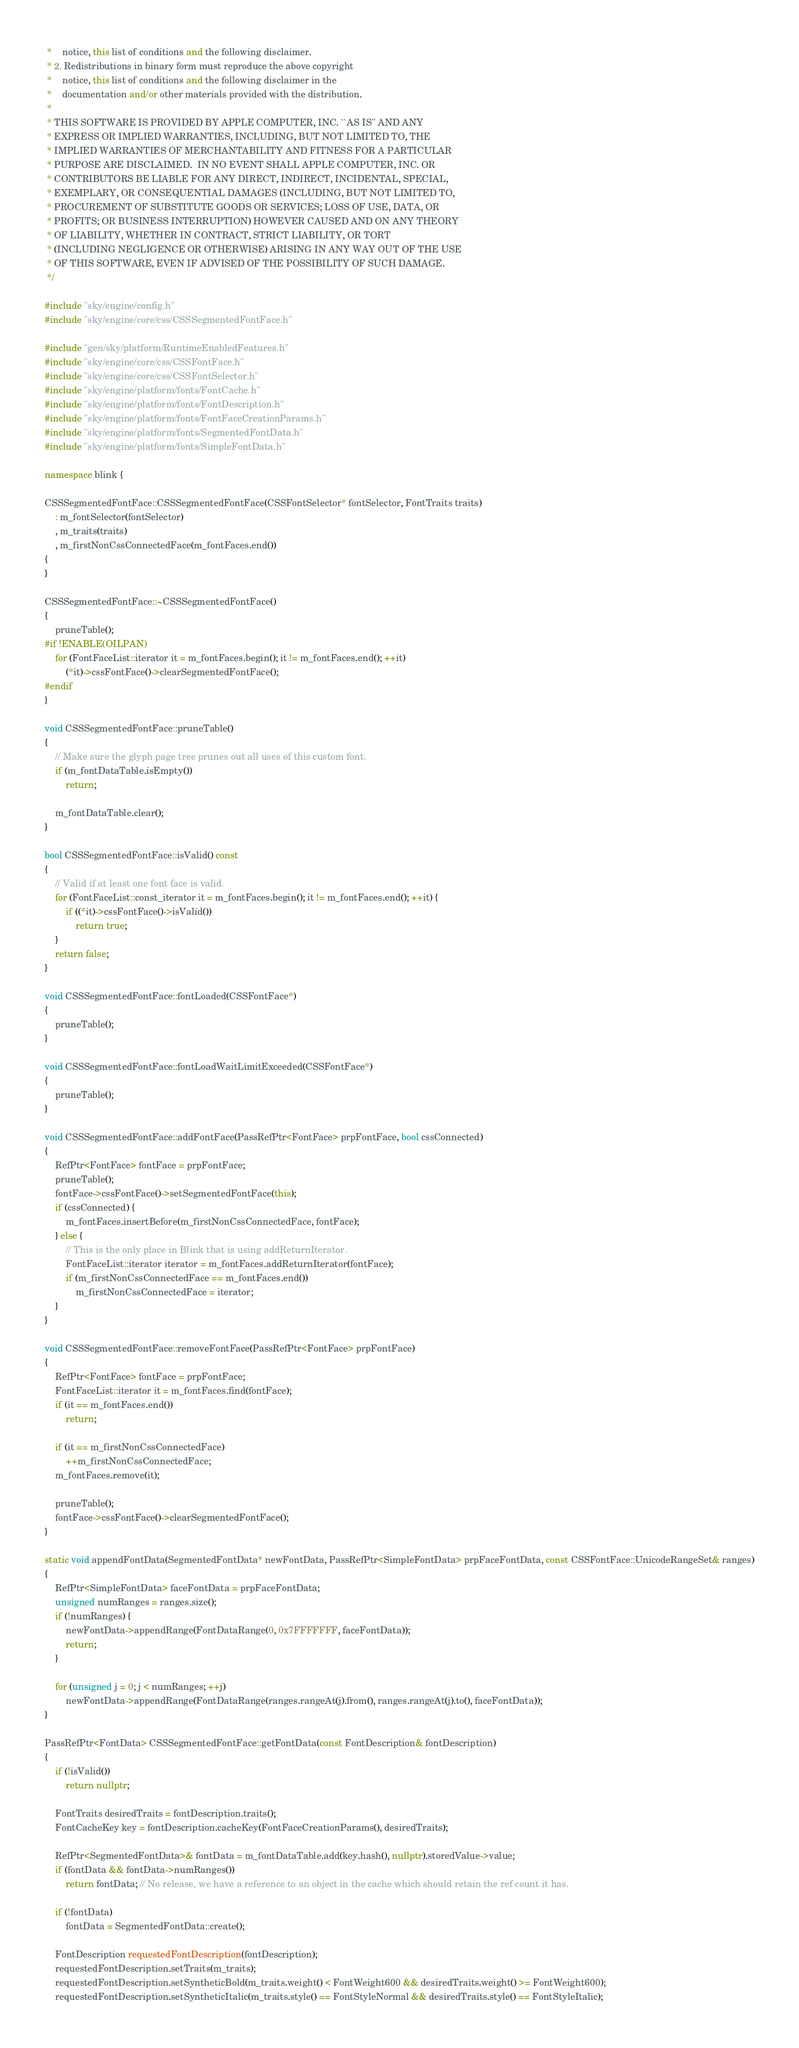Convert code to text. <code><loc_0><loc_0><loc_500><loc_500><_C++_> *    notice, this list of conditions and the following disclaimer.
 * 2. Redistributions in binary form must reproduce the above copyright
 *    notice, this list of conditions and the following disclaimer in the
 *    documentation and/or other materials provided with the distribution.
 *
 * THIS SOFTWARE IS PROVIDED BY APPLE COMPUTER, INC. ``AS IS'' AND ANY
 * EXPRESS OR IMPLIED WARRANTIES, INCLUDING, BUT NOT LIMITED TO, THE
 * IMPLIED WARRANTIES OF MERCHANTABILITY AND FITNESS FOR A PARTICULAR
 * PURPOSE ARE DISCLAIMED.  IN NO EVENT SHALL APPLE COMPUTER, INC. OR
 * CONTRIBUTORS BE LIABLE FOR ANY DIRECT, INDIRECT, INCIDENTAL, SPECIAL,
 * EXEMPLARY, OR CONSEQUENTIAL DAMAGES (INCLUDING, BUT NOT LIMITED TO,
 * PROCUREMENT OF SUBSTITUTE GOODS OR SERVICES; LOSS OF USE, DATA, OR
 * PROFITS; OR BUSINESS INTERRUPTION) HOWEVER CAUSED AND ON ANY THEORY
 * OF LIABILITY, WHETHER IN CONTRACT, STRICT LIABILITY, OR TORT
 * (INCLUDING NEGLIGENCE OR OTHERWISE) ARISING IN ANY WAY OUT OF THE USE
 * OF THIS SOFTWARE, EVEN IF ADVISED OF THE POSSIBILITY OF SUCH DAMAGE.
 */

#include "sky/engine/config.h"
#include "sky/engine/core/css/CSSSegmentedFontFace.h"

#include "gen/sky/platform/RuntimeEnabledFeatures.h"
#include "sky/engine/core/css/CSSFontFace.h"
#include "sky/engine/core/css/CSSFontSelector.h"
#include "sky/engine/platform/fonts/FontCache.h"
#include "sky/engine/platform/fonts/FontDescription.h"
#include "sky/engine/platform/fonts/FontFaceCreationParams.h"
#include "sky/engine/platform/fonts/SegmentedFontData.h"
#include "sky/engine/platform/fonts/SimpleFontData.h"

namespace blink {

CSSSegmentedFontFace::CSSSegmentedFontFace(CSSFontSelector* fontSelector, FontTraits traits)
    : m_fontSelector(fontSelector)
    , m_traits(traits)
    , m_firstNonCssConnectedFace(m_fontFaces.end())
{
}

CSSSegmentedFontFace::~CSSSegmentedFontFace()
{
    pruneTable();
#if !ENABLE(OILPAN)
    for (FontFaceList::iterator it = m_fontFaces.begin(); it != m_fontFaces.end(); ++it)
        (*it)->cssFontFace()->clearSegmentedFontFace();
#endif
}

void CSSSegmentedFontFace::pruneTable()
{
    // Make sure the glyph page tree prunes out all uses of this custom font.
    if (m_fontDataTable.isEmpty())
        return;

    m_fontDataTable.clear();
}

bool CSSSegmentedFontFace::isValid() const
{
    // Valid if at least one font face is valid.
    for (FontFaceList::const_iterator it = m_fontFaces.begin(); it != m_fontFaces.end(); ++it) {
        if ((*it)->cssFontFace()->isValid())
            return true;
    }
    return false;
}

void CSSSegmentedFontFace::fontLoaded(CSSFontFace*)
{
    pruneTable();
}

void CSSSegmentedFontFace::fontLoadWaitLimitExceeded(CSSFontFace*)
{
    pruneTable();
}

void CSSSegmentedFontFace::addFontFace(PassRefPtr<FontFace> prpFontFace, bool cssConnected)
{
    RefPtr<FontFace> fontFace = prpFontFace;
    pruneTable();
    fontFace->cssFontFace()->setSegmentedFontFace(this);
    if (cssConnected) {
        m_fontFaces.insertBefore(m_firstNonCssConnectedFace, fontFace);
    } else {
        // This is the only place in Blink that is using addReturnIterator.
        FontFaceList::iterator iterator = m_fontFaces.addReturnIterator(fontFace);
        if (m_firstNonCssConnectedFace == m_fontFaces.end())
            m_firstNonCssConnectedFace = iterator;
    }
}

void CSSSegmentedFontFace::removeFontFace(PassRefPtr<FontFace> prpFontFace)
{
    RefPtr<FontFace> fontFace = prpFontFace;
    FontFaceList::iterator it = m_fontFaces.find(fontFace);
    if (it == m_fontFaces.end())
        return;

    if (it == m_firstNonCssConnectedFace)
        ++m_firstNonCssConnectedFace;
    m_fontFaces.remove(it);

    pruneTable();
    fontFace->cssFontFace()->clearSegmentedFontFace();
}

static void appendFontData(SegmentedFontData* newFontData, PassRefPtr<SimpleFontData> prpFaceFontData, const CSSFontFace::UnicodeRangeSet& ranges)
{
    RefPtr<SimpleFontData> faceFontData = prpFaceFontData;
    unsigned numRanges = ranges.size();
    if (!numRanges) {
        newFontData->appendRange(FontDataRange(0, 0x7FFFFFFF, faceFontData));
        return;
    }

    for (unsigned j = 0; j < numRanges; ++j)
        newFontData->appendRange(FontDataRange(ranges.rangeAt(j).from(), ranges.rangeAt(j).to(), faceFontData));
}

PassRefPtr<FontData> CSSSegmentedFontFace::getFontData(const FontDescription& fontDescription)
{
    if (!isValid())
        return nullptr;

    FontTraits desiredTraits = fontDescription.traits();
    FontCacheKey key = fontDescription.cacheKey(FontFaceCreationParams(), desiredTraits);

    RefPtr<SegmentedFontData>& fontData = m_fontDataTable.add(key.hash(), nullptr).storedValue->value;
    if (fontData && fontData->numRanges())
        return fontData; // No release, we have a reference to an object in the cache which should retain the ref count it has.

    if (!fontData)
        fontData = SegmentedFontData::create();

    FontDescription requestedFontDescription(fontDescription);
    requestedFontDescription.setTraits(m_traits);
    requestedFontDescription.setSyntheticBold(m_traits.weight() < FontWeight600 && desiredTraits.weight() >= FontWeight600);
    requestedFontDescription.setSyntheticItalic(m_traits.style() == FontStyleNormal && desiredTraits.style() == FontStyleItalic);
</code> 